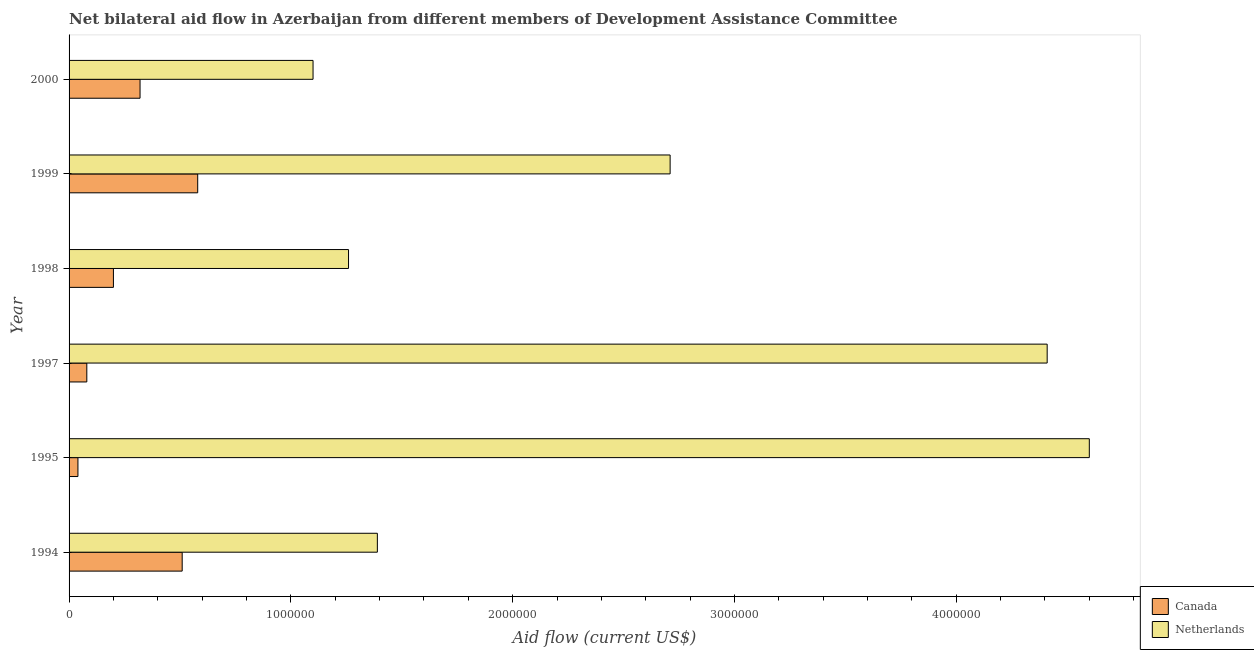How many different coloured bars are there?
Your response must be concise. 2. How many groups of bars are there?
Provide a succinct answer. 6. How many bars are there on the 2nd tick from the bottom?
Your answer should be compact. 2. What is the amount of aid given by netherlands in 1999?
Provide a short and direct response. 2.71e+06. Across all years, what is the maximum amount of aid given by canada?
Your answer should be very brief. 5.80e+05. Across all years, what is the minimum amount of aid given by canada?
Keep it short and to the point. 4.00e+04. In which year was the amount of aid given by canada minimum?
Keep it short and to the point. 1995. What is the total amount of aid given by canada in the graph?
Your answer should be very brief. 1.73e+06. What is the difference between the amount of aid given by netherlands in 1995 and that in 1997?
Keep it short and to the point. 1.90e+05. What is the difference between the amount of aid given by canada in 1999 and the amount of aid given by netherlands in 1994?
Give a very brief answer. -8.10e+05. What is the average amount of aid given by netherlands per year?
Keep it short and to the point. 2.58e+06. In the year 1998, what is the difference between the amount of aid given by netherlands and amount of aid given by canada?
Ensure brevity in your answer.  1.06e+06. What is the ratio of the amount of aid given by canada in 1994 to that in 1999?
Your response must be concise. 0.88. Is the amount of aid given by canada in 1997 less than that in 2000?
Offer a terse response. Yes. Is the difference between the amount of aid given by netherlands in 1995 and 2000 greater than the difference between the amount of aid given by canada in 1995 and 2000?
Keep it short and to the point. Yes. What is the difference between the highest and the second highest amount of aid given by canada?
Your answer should be very brief. 7.00e+04. What is the difference between the highest and the lowest amount of aid given by canada?
Offer a terse response. 5.40e+05. In how many years, is the amount of aid given by canada greater than the average amount of aid given by canada taken over all years?
Offer a very short reply. 3. What does the 1st bar from the bottom in 1995 represents?
Give a very brief answer. Canada. How many bars are there?
Offer a terse response. 12. How many years are there in the graph?
Offer a very short reply. 6. Does the graph contain any zero values?
Provide a short and direct response. No. Does the graph contain grids?
Give a very brief answer. No. Where does the legend appear in the graph?
Make the answer very short. Bottom right. How are the legend labels stacked?
Your answer should be compact. Vertical. What is the title of the graph?
Provide a succinct answer. Net bilateral aid flow in Azerbaijan from different members of Development Assistance Committee. Does "Urban" appear as one of the legend labels in the graph?
Offer a very short reply. No. What is the label or title of the X-axis?
Provide a succinct answer. Aid flow (current US$). What is the Aid flow (current US$) of Canada in 1994?
Provide a short and direct response. 5.10e+05. What is the Aid flow (current US$) of Netherlands in 1994?
Your answer should be very brief. 1.39e+06. What is the Aid flow (current US$) in Netherlands in 1995?
Make the answer very short. 4.60e+06. What is the Aid flow (current US$) of Canada in 1997?
Give a very brief answer. 8.00e+04. What is the Aid flow (current US$) of Netherlands in 1997?
Your answer should be compact. 4.41e+06. What is the Aid flow (current US$) of Canada in 1998?
Offer a very short reply. 2.00e+05. What is the Aid flow (current US$) of Netherlands in 1998?
Your answer should be compact. 1.26e+06. What is the Aid flow (current US$) of Canada in 1999?
Your answer should be compact. 5.80e+05. What is the Aid flow (current US$) of Netherlands in 1999?
Make the answer very short. 2.71e+06. What is the Aid flow (current US$) in Canada in 2000?
Offer a terse response. 3.20e+05. What is the Aid flow (current US$) of Netherlands in 2000?
Provide a short and direct response. 1.10e+06. Across all years, what is the maximum Aid flow (current US$) of Canada?
Offer a terse response. 5.80e+05. Across all years, what is the maximum Aid flow (current US$) of Netherlands?
Provide a succinct answer. 4.60e+06. Across all years, what is the minimum Aid flow (current US$) of Netherlands?
Your answer should be compact. 1.10e+06. What is the total Aid flow (current US$) in Canada in the graph?
Keep it short and to the point. 1.73e+06. What is the total Aid flow (current US$) of Netherlands in the graph?
Offer a terse response. 1.55e+07. What is the difference between the Aid flow (current US$) in Canada in 1994 and that in 1995?
Provide a short and direct response. 4.70e+05. What is the difference between the Aid flow (current US$) in Netherlands in 1994 and that in 1995?
Offer a very short reply. -3.21e+06. What is the difference between the Aid flow (current US$) in Canada in 1994 and that in 1997?
Your response must be concise. 4.30e+05. What is the difference between the Aid flow (current US$) of Netherlands in 1994 and that in 1997?
Ensure brevity in your answer.  -3.02e+06. What is the difference between the Aid flow (current US$) in Canada in 1994 and that in 1998?
Provide a short and direct response. 3.10e+05. What is the difference between the Aid flow (current US$) in Canada in 1994 and that in 1999?
Offer a very short reply. -7.00e+04. What is the difference between the Aid flow (current US$) of Netherlands in 1994 and that in 1999?
Your answer should be very brief. -1.32e+06. What is the difference between the Aid flow (current US$) in Canada in 1994 and that in 2000?
Ensure brevity in your answer.  1.90e+05. What is the difference between the Aid flow (current US$) of Netherlands in 1995 and that in 1998?
Your response must be concise. 3.34e+06. What is the difference between the Aid flow (current US$) in Canada in 1995 and that in 1999?
Provide a succinct answer. -5.40e+05. What is the difference between the Aid flow (current US$) of Netherlands in 1995 and that in 1999?
Your answer should be compact. 1.89e+06. What is the difference between the Aid flow (current US$) in Canada in 1995 and that in 2000?
Provide a succinct answer. -2.80e+05. What is the difference between the Aid flow (current US$) of Netherlands in 1995 and that in 2000?
Keep it short and to the point. 3.50e+06. What is the difference between the Aid flow (current US$) in Netherlands in 1997 and that in 1998?
Provide a short and direct response. 3.15e+06. What is the difference between the Aid flow (current US$) in Canada in 1997 and that in 1999?
Keep it short and to the point. -5.00e+05. What is the difference between the Aid flow (current US$) in Netherlands in 1997 and that in 1999?
Ensure brevity in your answer.  1.70e+06. What is the difference between the Aid flow (current US$) in Canada in 1997 and that in 2000?
Provide a succinct answer. -2.40e+05. What is the difference between the Aid flow (current US$) of Netherlands in 1997 and that in 2000?
Ensure brevity in your answer.  3.31e+06. What is the difference between the Aid flow (current US$) in Canada in 1998 and that in 1999?
Your response must be concise. -3.80e+05. What is the difference between the Aid flow (current US$) in Netherlands in 1998 and that in 1999?
Your answer should be very brief. -1.45e+06. What is the difference between the Aid flow (current US$) of Canada in 1998 and that in 2000?
Your answer should be very brief. -1.20e+05. What is the difference between the Aid flow (current US$) in Netherlands in 1998 and that in 2000?
Your answer should be very brief. 1.60e+05. What is the difference between the Aid flow (current US$) in Netherlands in 1999 and that in 2000?
Offer a very short reply. 1.61e+06. What is the difference between the Aid flow (current US$) in Canada in 1994 and the Aid flow (current US$) in Netherlands in 1995?
Offer a terse response. -4.09e+06. What is the difference between the Aid flow (current US$) of Canada in 1994 and the Aid flow (current US$) of Netherlands in 1997?
Keep it short and to the point. -3.90e+06. What is the difference between the Aid flow (current US$) in Canada in 1994 and the Aid flow (current US$) in Netherlands in 1998?
Offer a very short reply. -7.50e+05. What is the difference between the Aid flow (current US$) in Canada in 1994 and the Aid flow (current US$) in Netherlands in 1999?
Give a very brief answer. -2.20e+06. What is the difference between the Aid flow (current US$) in Canada in 1994 and the Aid flow (current US$) in Netherlands in 2000?
Provide a succinct answer. -5.90e+05. What is the difference between the Aid flow (current US$) of Canada in 1995 and the Aid flow (current US$) of Netherlands in 1997?
Ensure brevity in your answer.  -4.37e+06. What is the difference between the Aid flow (current US$) in Canada in 1995 and the Aid flow (current US$) in Netherlands in 1998?
Offer a terse response. -1.22e+06. What is the difference between the Aid flow (current US$) in Canada in 1995 and the Aid flow (current US$) in Netherlands in 1999?
Ensure brevity in your answer.  -2.67e+06. What is the difference between the Aid flow (current US$) of Canada in 1995 and the Aid flow (current US$) of Netherlands in 2000?
Give a very brief answer. -1.06e+06. What is the difference between the Aid flow (current US$) in Canada in 1997 and the Aid flow (current US$) in Netherlands in 1998?
Provide a succinct answer. -1.18e+06. What is the difference between the Aid flow (current US$) in Canada in 1997 and the Aid flow (current US$) in Netherlands in 1999?
Make the answer very short. -2.63e+06. What is the difference between the Aid flow (current US$) of Canada in 1997 and the Aid flow (current US$) of Netherlands in 2000?
Offer a very short reply. -1.02e+06. What is the difference between the Aid flow (current US$) in Canada in 1998 and the Aid flow (current US$) in Netherlands in 1999?
Your response must be concise. -2.51e+06. What is the difference between the Aid flow (current US$) in Canada in 1998 and the Aid flow (current US$) in Netherlands in 2000?
Your answer should be compact. -9.00e+05. What is the difference between the Aid flow (current US$) in Canada in 1999 and the Aid flow (current US$) in Netherlands in 2000?
Provide a short and direct response. -5.20e+05. What is the average Aid flow (current US$) in Canada per year?
Keep it short and to the point. 2.88e+05. What is the average Aid flow (current US$) of Netherlands per year?
Give a very brief answer. 2.58e+06. In the year 1994, what is the difference between the Aid flow (current US$) of Canada and Aid flow (current US$) of Netherlands?
Your response must be concise. -8.80e+05. In the year 1995, what is the difference between the Aid flow (current US$) of Canada and Aid flow (current US$) of Netherlands?
Your answer should be very brief. -4.56e+06. In the year 1997, what is the difference between the Aid flow (current US$) in Canada and Aid flow (current US$) in Netherlands?
Ensure brevity in your answer.  -4.33e+06. In the year 1998, what is the difference between the Aid flow (current US$) in Canada and Aid flow (current US$) in Netherlands?
Your answer should be compact. -1.06e+06. In the year 1999, what is the difference between the Aid flow (current US$) of Canada and Aid flow (current US$) of Netherlands?
Keep it short and to the point. -2.13e+06. In the year 2000, what is the difference between the Aid flow (current US$) of Canada and Aid flow (current US$) of Netherlands?
Your answer should be very brief. -7.80e+05. What is the ratio of the Aid flow (current US$) of Canada in 1994 to that in 1995?
Make the answer very short. 12.75. What is the ratio of the Aid flow (current US$) of Netherlands in 1994 to that in 1995?
Offer a very short reply. 0.3. What is the ratio of the Aid flow (current US$) of Canada in 1994 to that in 1997?
Provide a succinct answer. 6.38. What is the ratio of the Aid flow (current US$) in Netherlands in 1994 to that in 1997?
Make the answer very short. 0.32. What is the ratio of the Aid flow (current US$) of Canada in 1994 to that in 1998?
Your answer should be compact. 2.55. What is the ratio of the Aid flow (current US$) of Netherlands in 1994 to that in 1998?
Offer a very short reply. 1.1. What is the ratio of the Aid flow (current US$) in Canada in 1994 to that in 1999?
Your answer should be very brief. 0.88. What is the ratio of the Aid flow (current US$) in Netherlands in 1994 to that in 1999?
Make the answer very short. 0.51. What is the ratio of the Aid flow (current US$) of Canada in 1994 to that in 2000?
Make the answer very short. 1.59. What is the ratio of the Aid flow (current US$) in Netherlands in 1994 to that in 2000?
Keep it short and to the point. 1.26. What is the ratio of the Aid flow (current US$) of Netherlands in 1995 to that in 1997?
Make the answer very short. 1.04. What is the ratio of the Aid flow (current US$) in Canada in 1995 to that in 1998?
Your answer should be very brief. 0.2. What is the ratio of the Aid flow (current US$) in Netherlands in 1995 to that in 1998?
Offer a very short reply. 3.65. What is the ratio of the Aid flow (current US$) of Canada in 1995 to that in 1999?
Provide a short and direct response. 0.07. What is the ratio of the Aid flow (current US$) of Netherlands in 1995 to that in 1999?
Provide a short and direct response. 1.7. What is the ratio of the Aid flow (current US$) in Netherlands in 1995 to that in 2000?
Ensure brevity in your answer.  4.18. What is the ratio of the Aid flow (current US$) of Canada in 1997 to that in 1998?
Your answer should be compact. 0.4. What is the ratio of the Aid flow (current US$) of Netherlands in 1997 to that in 1998?
Provide a succinct answer. 3.5. What is the ratio of the Aid flow (current US$) of Canada in 1997 to that in 1999?
Your answer should be compact. 0.14. What is the ratio of the Aid flow (current US$) in Netherlands in 1997 to that in 1999?
Keep it short and to the point. 1.63. What is the ratio of the Aid flow (current US$) in Canada in 1997 to that in 2000?
Your answer should be compact. 0.25. What is the ratio of the Aid flow (current US$) in Netherlands in 1997 to that in 2000?
Keep it short and to the point. 4.01. What is the ratio of the Aid flow (current US$) of Canada in 1998 to that in 1999?
Make the answer very short. 0.34. What is the ratio of the Aid flow (current US$) of Netherlands in 1998 to that in 1999?
Offer a very short reply. 0.46. What is the ratio of the Aid flow (current US$) in Canada in 1998 to that in 2000?
Make the answer very short. 0.62. What is the ratio of the Aid flow (current US$) of Netherlands in 1998 to that in 2000?
Give a very brief answer. 1.15. What is the ratio of the Aid flow (current US$) of Canada in 1999 to that in 2000?
Ensure brevity in your answer.  1.81. What is the ratio of the Aid flow (current US$) of Netherlands in 1999 to that in 2000?
Ensure brevity in your answer.  2.46. What is the difference between the highest and the second highest Aid flow (current US$) of Netherlands?
Offer a very short reply. 1.90e+05. What is the difference between the highest and the lowest Aid flow (current US$) in Canada?
Make the answer very short. 5.40e+05. What is the difference between the highest and the lowest Aid flow (current US$) of Netherlands?
Offer a very short reply. 3.50e+06. 